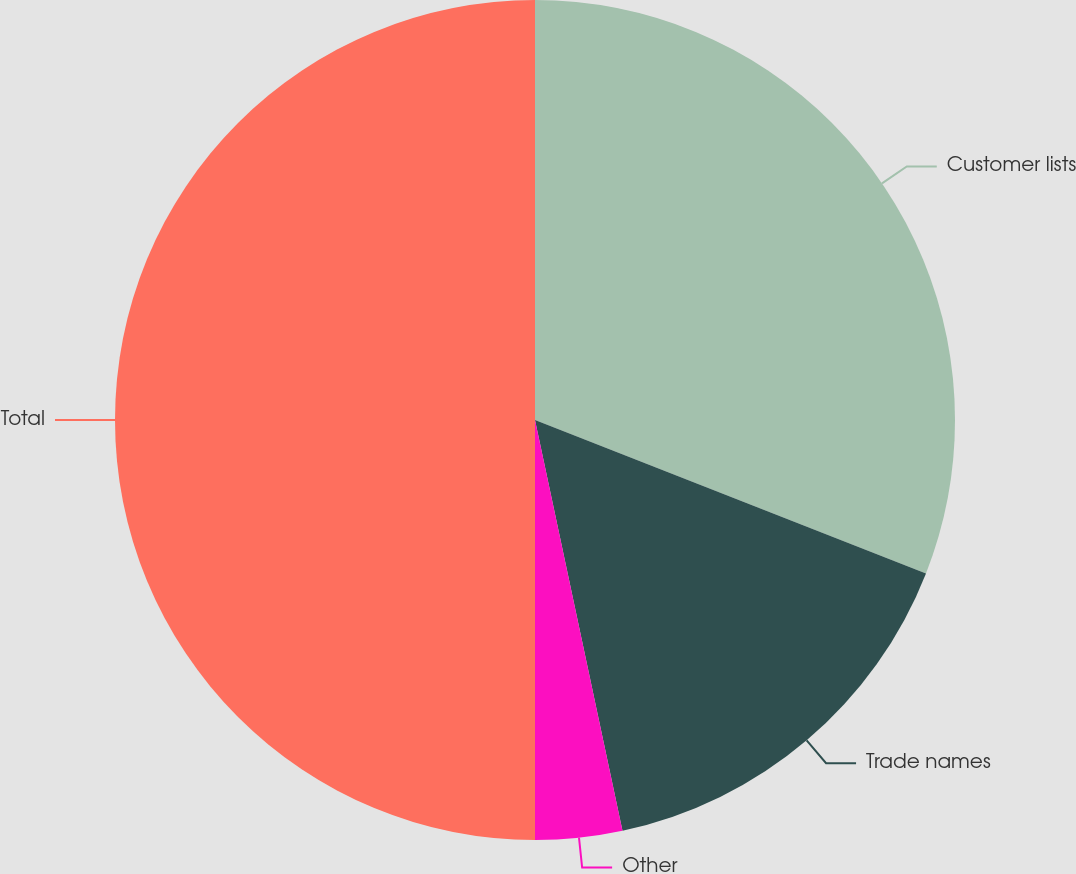<chart> <loc_0><loc_0><loc_500><loc_500><pie_chart><fcel>Customer lists<fcel>Trade names<fcel>Other<fcel>Total<nl><fcel>30.95%<fcel>15.71%<fcel>3.34%<fcel>50.0%<nl></chart> 